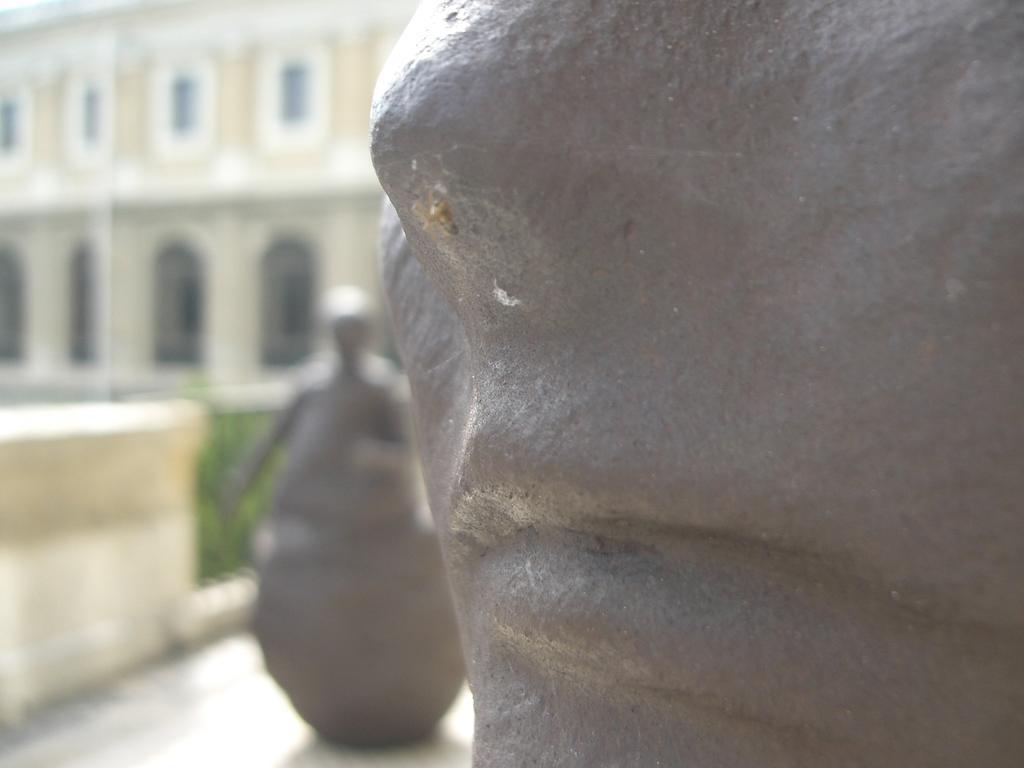Could you give a brief overview of what you see in this image? In this image I can see few statues in gray color, background I can see few plants in green color and the building is in cream and white color. 